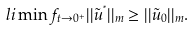Convert formula to latex. <formula><loc_0><loc_0><loc_500><loc_500>l i \min f _ { t \rightarrow 0 ^ { + } } | | \tilde { u } ^ { ^ { * } } | | _ { m } \geq | | \tilde { u } _ { 0 } | | _ { m } .</formula> 